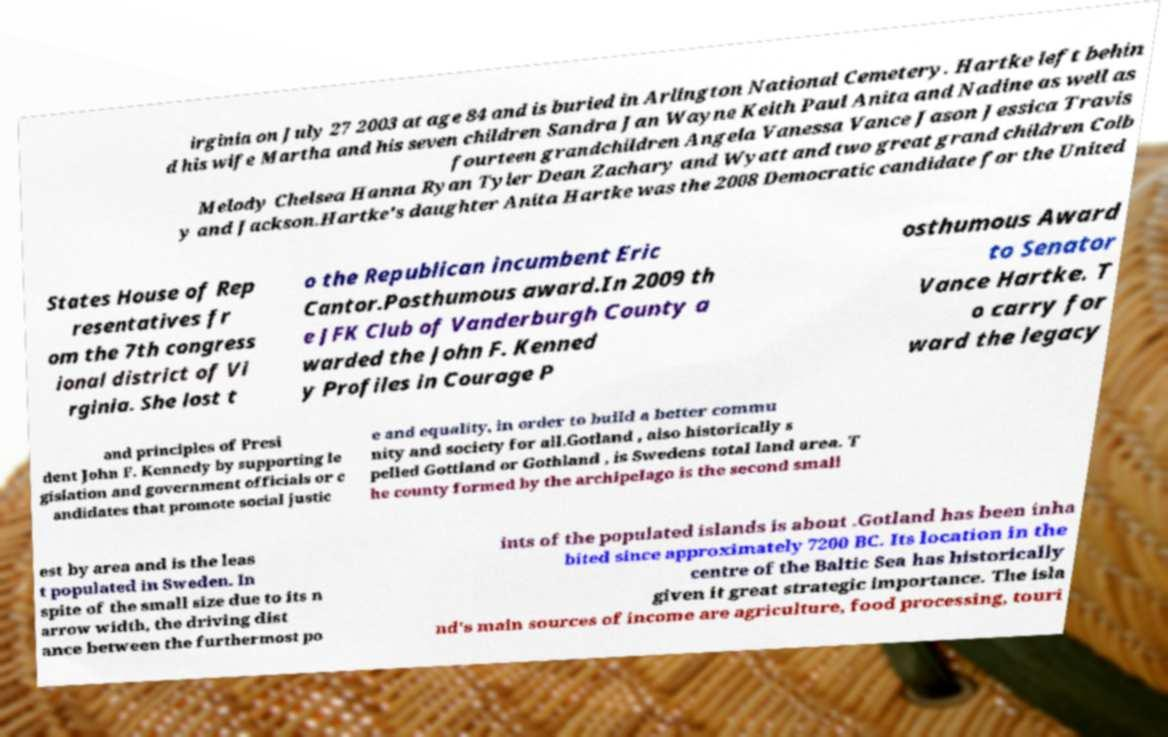Please read and relay the text visible in this image. What does it say? irginia on July 27 2003 at age 84 and is buried in Arlington National Cemetery. Hartke left behin d his wife Martha and his seven children Sandra Jan Wayne Keith Paul Anita and Nadine as well as fourteen grandchildren Angela Vanessa Vance Jason Jessica Travis Melody Chelsea Hanna Ryan Tyler Dean Zachary and Wyatt and two great grand children Colb y and Jackson.Hartke's daughter Anita Hartke was the 2008 Democratic candidate for the United States House of Rep resentatives fr om the 7th congress ional district of Vi rginia. She lost t o the Republican incumbent Eric Cantor.Posthumous award.In 2009 th e JFK Club of Vanderburgh County a warded the John F. Kenned y Profiles in Courage P osthumous Award to Senator Vance Hartke. T o carry for ward the legacy and principles of Presi dent John F. Kennedy by supporting le gislation and government officials or c andidates that promote social justic e and equality, in order to build a better commu nity and society for all.Gotland , also historically s pelled Gottland or Gothland , is Swedens total land area. T he county formed by the archipelago is the second small est by area and is the leas t populated in Sweden. In spite of the small size due to its n arrow width, the driving dist ance between the furthermost po ints of the populated islands is about .Gotland has been inha bited since approximately 7200 BC. Its location in the centre of the Baltic Sea has historically given it great strategic importance. The isla nd's main sources of income are agriculture, food processing, touri 